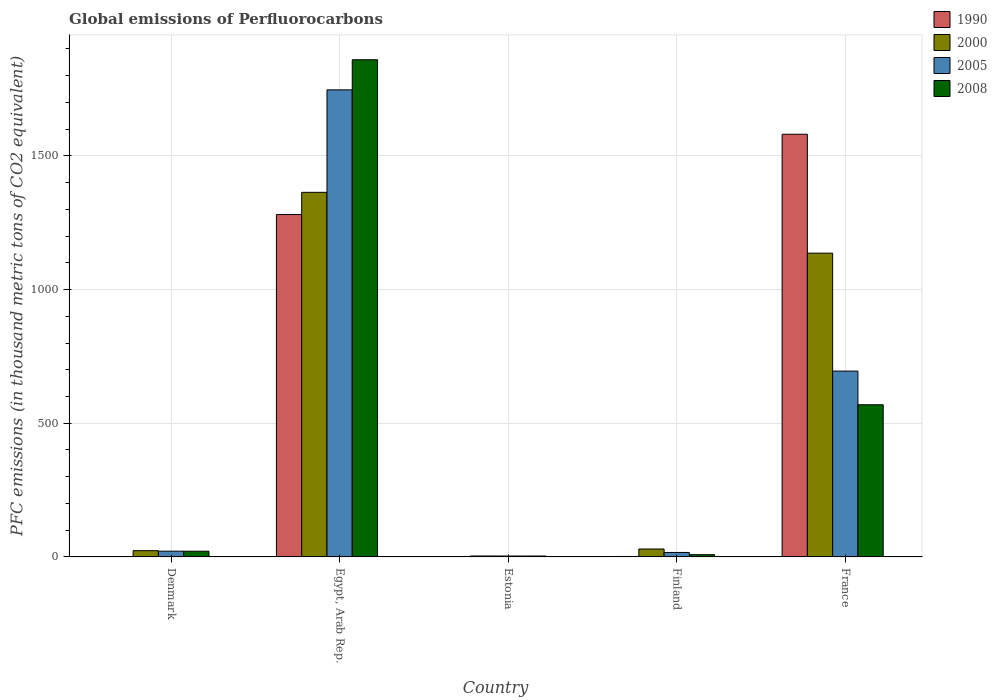How many groups of bars are there?
Your answer should be very brief. 5. What is the label of the 5th group of bars from the left?
Your answer should be very brief. France. In how many cases, is the number of bars for a given country not equal to the number of legend labels?
Your answer should be very brief. 0. Across all countries, what is the maximum global emissions of Perfluorocarbons in 2000?
Provide a succinct answer. 1363.8. Across all countries, what is the minimum global emissions of Perfluorocarbons in 2005?
Provide a short and direct response. 3.4. In which country was the global emissions of Perfluorocarbons in 2008 maximum?
Keep it short and to the point. Egypt, Arab Rep. In which country was the global emissions of Perfluorocarbons in 2005 minimum?
Provide a succinct answer. Estonia. What is the total global emissions of Perfluorocarbons in 2000 in the graph?
Make the answer very short. 2556.7. What is the difference between the global emissions of Perfluorocarbons in 2000 in Denmark and that in Finland?
Your answer should be compact. -6.3. What is the difference between the global emissions of Perfluorocarbons in 2005 in Denmark and the global emissions of Perfluorocarbons in 1990 in Finland?
Make the answer very short. 19.8. What is the average global emissions of Perfluorocarbons in 1990 per country?
Keep it short and to the point. 573.1. What is the difference between the global emissions of Perfluorocarbons of/in 2005 and global emissions of Perfluorocarbons of/in 2008 in Egypt, Arab Rep.?
Offer a very short reply. -112.7. What is the ratio of the global emissions of Perfluorocarbons in 1990 in Egypt, Arab Rep. to that in Finland?
Your answer should be very brief. 753.41. Is the global emissions of Perfluorocarbons in 2005 in Denmark less than that in Finland?
Provide a short and direct response. No. What is the difference between the highest and the second highest global emissions of Perfluorocarbons in 2005?
Provide a succinct answer. 1725.6. What is the difference between the highest and the lowest global emissions of Perfluorocarbons in 2000?
Offer a terse response. 1360.3. In how many countries, is the global emissions of Perfluorocarbons in 2008 greater than the average global emissions of Perfluorocarbons in 2008 taken over all countries?
Give a very brief answer. 2. Are all the bars in the graph horizontal?
Your answer should be very brief. No. How many countries are there in the graph?
Offer a terse response. 5. What is the difference between two consecutive major ticks on the Y-axis?
Provide a short and direct response. 500. Are the values on the major ticks of Y-axis written in scientific E-notation?
Provide a short and direct response. No. Where does the legend appear in the graph?
Your answer should be compact. Top right. How many legend labels are there?
Make the answer very short. 4. How are the legend labels stacked?
Your response must be concise. Vertical. What is the title of the graph?
Make the answer very short. Global emissions of Perfluorocarbons. Does "1989" appear as one of the legend labels in the graph?
Your answer should be very brief. No. What is the label or title of the X-axis?
Provide a short and direct response. Country. What is the label or title of the Y-axis?
Give a very brief answer. PFC emissions (in thousand metric tons of CO2 equivalent). What is the PFC emissions (in thousand metric tons of CO2 equivalent) of 2000 in Denmark?
Offer a terse response. 23.4. What is the PFC emissions (in thousand metric tons of CO2 equivalent) in 2005 in Denmark?
Make the answer very short. 21.5. What is the PFC emissions (in thousand metric tons of CO2 equivalent) in 2008 in Denmark?
Make the answer very short. 21.4. What is the PFC emissions (in thousand metric tons of CO2 equivalent) of 1990 in Egypt, Arab Rep.?
Keep it short and to the point. 1280.8. What is the PFC emissions (in thousand metric tons of CO2 equivalent) of 2000 in Egypt, Arab Rep.?
Your response must be concise. 1363.8. What is the PFC emissions (in thousand metric tons of CO2 equivalent) of 2005 in Egypt, Arab Rep.?
Your response must be concise. 1747.1. What is the PFC emissions (in thousand metric tons of CO2 equivalent) in 2008 in Egypt, Arab Rep.?
Offer a very short reply. 1859.8. What is the PFC emissions (in thousand metric tons of CO2 equivalent) in 1990 in Estonia?
Provide a succinct answer. 0.5. What is the PFC emissions (in thousand metric tons of CO2 equivalent) of 2008 in Estonia?
Offer a terse response. 3.4. What is the PFC emissions (in thousand metric tons of CO2 equivalent) in 2000 in Finland?
Make the answer very short. 29.7. What is the PFC emissions (in thousand metric tons of CO2 equivalent) in 2005 in Finland?
Your response must be concise. 16.7. What is the PFC emissions (in thousand metric tons of CO2 equivalent) of 1990 in France?
Offer a terse response. 1581.1. What is the PFC emissions (in thousand metric tons of CO2 equivalent) in 2000 in France?
Offer a very short reply. 1136.3. What is the PFC emissions (in thousand metric tons of CO2 equivalent) of 2005 in France?
Your response must be concise. 695.1. What is the PFC emissions (in thousand metric tons of CO2 equivalent) in 2008 in France?
Offer a very short reply. 569.2. Across all countries, what is the maximum PFC emissions (in thousand metric tons of CO2 equivalent) in 1990?
Keep it short and to the point. 1581.1. Across all countries, what is the maximum PFC emissions (in thousand metric tons of CO2 equivalent) in 2000?
Your answer should be very brief. 1363.8. Across all countries, what is the maximum PFC emissions (in thousand metric tons of CO2 equivalent) in 2005?
Provide a succinct answer. 1747.1. Across all countries, what is the maximum PFC emissions (in thousand metric tons of CO2 equivalent) in 2008?
Provide a short and direct response. 1859.8. Across all countries, what is the minimum PFC emissions (in thousand metric tons of CO2 equivalent) of 2005?
Your answer should be compact. 3.4. Across all countries, what is the minimum PFC emissions (in thousand metric tons of CO2 equivalent) in 2008?
Give a very brief answer. 3.4. What is the total PFC emissions (in thousand metric tons of CO2 equivalent) in 1990 in the graph?
Make the answer very short. 2865.5. What is the total PFC emissions (in thousand metric tons of CO2 equivalent) in 2000 in the graph?
Your answer should be compact. 2556.7. What is the total PFC emissions (in thousand metric tons of CO2 equivalent) in 2005 in the graph?
Provide a short and direct response. 2483.8. What is the total PFC emissions (in thousand metric tons of CO2 equivalent) of 2008 in the graph?
Provide a short and direct response. 2462.2. What is the difference between the PFC emissions (in thousand metric tons of CO2 equivalent) of 1990 in Denmark and that in Egypt, Arab Rep.?
Your response must be concise. -1279.4. What is the difference between the PFC emissions (in thousand metric tons of CO2 equivalent) of 2000 in Denmark and that in Egypt, Arab Rep.?
Your response must be concise. -1340.4. What is the difference between the PFC emissions (in thousand metric tons of CO2 equivalent) of 2005 in Denmark and that in Egypt, Arab Rep.?
Give a very brief answer. -1725.6. What is the difference between the PFC emissions (in thousand metric tons of CO2 equivalent) of 2008 in Denmark and that in Egypt, Arab Rep.?
Give a very brief answer. -1838.4. What is the difference between the PFC emissions (in thousand metric tons of CO2 equivalent) of 1990 in Denmark and that in Estonia?
Ensure brevity in your answer.  0.9. What is the difference between the PFC emissions (in thousand metric tons of CO2 equivalent) of 2005 in Denmark and that in Estonia?
Your response must be concise. 18.1. What is the difference between the PFC emissions (in thousand metric tons of CO2 equivalent) of 2000 in Denmark and that in Finland?
Provide a short and direct response. -6.3. What is the difference between the PFC emissions (in thousand metric tons of CO2 equivalent) in 1990 in Denmark and that in France?
Make the answer very short. -1579.7. What is the difference between the PFC emissions (in thousand metric tons of CO2 equivalent) in 2000 in Denmark and that in France?
Your answer should be compact. -1112.9. What is the difference between the PFC emissions (in thousand metric tons of CO2 equivalent) in 2005 in Denmark and that in France?
Offer a terse response. -673.6. What is the difference between the PFC emissions (in thousand metric tons of CO2 equivalent) in 2008 in Denmark and that in France?
Your answer should be very brief. -547.8. What is the difference between the PFC emissions (in thousand metric tons of CO2 equivalent) in 1990 in Egypt, Arab Rep. and that in Estonia?
Make the answer very short. 1280.3. What is the difference between the PFC emissions (in thousand metric tons of CO2 equivalent) of 2000 in Egypt, Arab Rep. and that in Estonia?
Offer a terse response. 1360.3. What is the difference between the PFC emissions (in thousand metric tons of CO2 equivalent) of 2005 in Egypt, Arab Rep. and that in Estonia?
Offer a very short reply. 1743.7. What is the difference between the PFC emissions (in thousand metric tons of CO2 equivalent) of 2008 in Egypt, Arab Rep. and that in Estonia?
Make the answer very short. 1856.4. What is the difference between the PFC emissions (in thousand metric tons of CO2 equivalent) in 1990 in Egypt, Arab Rep. and that in Finland?
Provide a succinct answer. 1279.1. What is the difference between the PFC emissions (in thousand metric tons of CO2 equivalent) of 2000 in Egypt, Arab Rep. and that in Finland?
Provide a succinct answer. 1334.1. What is the difference between the PFC emissions (in thousand metric tons of CO2 equivalent) of 2005 in Egypt, Arab Rep. and that in Finland?
Your answer should be very brief. 1730.4. What is the difference between the PFC emissions (in thousand metric tons of CO2 equivalent) in 2008 in Egypt, Arab Rep. and that in Finland?
Provide a succinct answer. 1851.4. What is the difference between the PFC emissions (in thousand metric tons of CO2 equivalent) in 1990 in Egypt, Arab Rep. and that in France?
Give a very brief answer. -300.3. What is the difference between the PFC emissions (in thousand metric tons of CO2 equivalent) in 2000 in Egypt, Arab Rep. and that in France?
Offer a terse response. 227.5. What is the difference between the PFC emissions (in thousand metric tons of CO2 equivalent) of 2005 in Egypt, Arab Rep. and that in France?
Your answer should be very brief. 1052. What is the difference between the PFC emissions (in thousand metric tons of CO2 equivalent) in 2008 in Egypt, Arab Rep. and that in France?
Ensure brevity in your answer.  1290.6. What is the difference between the PFC emissions (in thousand metric tons of CO2 equivalent) of 2000 in Estonia and that in Finland?
Your response must be concise. -26.2. What is the difference between the PFC emissions (in thousand metric tons of CO2 equivalent) in 1990 in Estonia and that in France?
Offer a terse response. -1580.6. What is the difference between the PFC emissions (in thousand metric tons of CO2 equivalent) of 2000 in Estonia and that in France?
Give a very brief answer. -1132.8. What is the difference between the PFC emissions (in thousand metric tons of CO2 equivalent) in 2005 in Estonia and that in France?
Offer a terse response. -691.7. What is the difference between the PFC emissions (in thousand metric tons of CO2 equivalent) of 2008 in Estonia and that in France?
Provide a succinct answer. -565.8. What is the difference between the PFC emissions (in thousand metric tons of CO2 equivalent) of 1990 in Finland and that in France?
Your response must be concise. -1579.4. What is the difference between the PFC emissions (in thousand metric tons of CO2 equivalent) in 2000 in Finland and that in France?
Make the answer very short. -1106.6. What is the difference between the PFC emissions (in thousand metric tons of CO2 equivalent) of 2005 in Finland and that in France?
Provide a short and direct response. -678.4. What is the difference between the PFC emissions (in thousand metric tons of CO2 equivalent) in 2008 in Finland and that in France?
Keep it short and to the point. -560.8. What is the difference between the PFC emissions (in thousand metric tons of CO2 equivalent) in 1990 in Denmark and the PFC emissions (in thousand metric tons of CO2 equivalent) in 2000 in Egypt, Arab Rep.?
Your response must be concise. -1362.4. What is the difference between the PFC emissions (in thousand metric tons of CO2 equivalent) in 1990 in Denmark and the PFC emissions (in thousand metric tons of CO2 equivalent) in 2005 in Egypt, Arab Rep.?
Your answer should be compact. -1745.7. What is the difference between the PFC emissions (in thousand metric tons of CO2 equivalent) of 1990 in Denmark and the PFC emissions (in thousand metric tons of CO2 equivalent) of 2008 in Egypt, Arab Rep.?
Give a very brief answer. -1858.4. What is the difference between the PFC emissions (in thousand metric tons of CO2 equivalent) in 2000 in Denmark and the PFC emissions (in thousand metric tons of CO2 equivalent) in 2005 in Egypt, Arab Rep.?
Keep it short and to the point. -1723.7. What is the difference between the PFC emissions (in thousand metric tons of CO2 equivalent) in 2000 in Denmark and the PFC emissions (in thousand metric tons of CO2 equivalent) in 2008 in Egypt, Arab Rep.?
Your answer should be very brief. -1836.4. What is the difference between the PFC emissions (in thousand metric tons of CO2 equivalent) of 2005 in Denmark and the PFC emissions (in thousand metric tons of CO2 equivalent) of 2008 in Egypt, Arab Rep.?
Your response must be concise. -1838.3. What is the difference between the PFC emissions (in thousand metric tons of CO2 equivalent) in 1990 in Denmark and the PFC emissions (in thousand metric tons of CO2 equivalent) in 2005 in Estonia?
Your answer should be very brief. -2. What is the difference between the PFC emissions (in thousand metric tons of CO2 equivalent) of 1990 in Denmark and the PFC emissions (in thousand metric tons of CO2 equivalent) of 2008 in Estonia?
Your answer should be compact. -2. What is the difference between the PFC emissions (in thousand metric tons of CO2 equivalent) in 2000 in Denmark and the PFC emissions (in thousand metric tons of CO2 equivalent) in 2008 in Estonia?
Offer a terse response. 20. What is the difference between the PFC emissions (in thousand metric tons of CO2 equivalent) in 2005 in Denmark and the PFC emissions (in thousand metric tons of CO2 equivalent) in 2008 in Estonia?
Offer a very short reply. 18.1. What is the difference between the PFC emissions (in thousand metric tons of CO2 equivalent) of 1990 in Denmark and the PFC emissions (in thousand metric tons of CO2 equivalent) of 2000 in Finland?
Make the answer very short. -28.3. What is the difference between the PFC emissions (in thousand metric tons of CO2 equivalent) of 1990 in Denmark and the PFC emissions (in thousand metric tons of CO2 equivalent) of 2005 in Finland?
Provide a succinct answer. -15.3. What is the difference between the PFC emissions (in thousand metric tons of CO2 equivalent) in 1990 in Denmark and the PFC emissions (in thousand metric tons of CO2 equivalent) in 2000 in France?
Provide a succinct answer. -1134.9. What is the difference between the PFC emissions (in thousand metric tons of CO2 equivalent) of 1990 in Denmark and the PFC emissions (in thousand metric tons of CO2 equivalent) of 2005 in France?
Your answer should be compact. -693.7. What is the difference between the PFC emissions (in thousand metric tons of CO2 equivalent) in 1990 in Denmark and the PFC emissions (in thousand metric tons of CO2 equivalent) in 2008 in France?
Give a very brief answer. -567.8. What is the difference between the PFC emissions (in thousand metric tons of CO2 equivalent) of 2000 in Denmark and the PFC emissions (in thousand metric tons of CO2 equivalent) of 2005 in France?
Your response must be concise. -671.7. What is the difference between the PFC emissions (in thousand metric tons of CO2 equivalent) of 2000 in Denmark and the PFC emissions (in thousand metric tons of CO2 equivalent) of 2008 in France?
Provide a succinct answer. -545.8. What is the difference between the PFC emissions (in thousand metric tons of CO2 equivalent) in 2005 in Denmark and the PFC emissions (in thousand metric tons of CO2 equivalent) in 2008 in France?
Ensure brevity in your answer.  -547.7. What is the difference between the PFC emissions (in thousand metric tons of CO2 equivalent) of 1990 in Egypt, Arab Rep. and the PFC emissions (in thousand metric tons of CO2 equivalent) of 2000 in Estonia?
Your response must be concise. 1277.3. What is the difference between the PFC emissions (in thousand metric tons of CO2 equivalent) in 1990 in Egypt, Arab Rep. and the PFC emissions (in thousand metric tons of CO2 equivalent) in 2005 in Estonia?
Your response must be concise. 1277.4. What is the difference between the PFC emissions (in thousand metric tons of CO2 equivalent) of 1990 in Egypt, Arab Rep. and the PFC emissions (in thousand metric tons of CO2 equivalent) of 2008 in Estonia?
Ensure brevity in your answer.  1277.4. What is the difference between the PFC emissions (in thousand metric tons of CO2 equivalent) in 2000 in Egypt, Arab Rep. and the PFC emissions (in thousand metric tons of CO2 equivalent) in 2005 in Estonia?
Offer a very short reply. 1360.4. What is the difference between the PFC emissions (in thousand metric tons of CO2 equivalent) in 2000 in Egypt, Arab Rep. and the PFC emissions (in thousand metric tons of CO2 equivalent) in 2008 in Estonia?
Provide a short and direct response. 1360.4. What is the difference between the PFC emissions (in thousand metric tons of CO2 equivalent) of 2005 in Egypt, Arab Rep. and the PFC emissions (in thousand metric tons of CO2 equivalent) of 2008 in Estonia?
Give a very brief answer. 1743.7. What is the difference between the PFC emissions (in thousand metric tons of CO2 equivalent) of 1990 in Egypt, Arab Rep. and the PFC emissions (in thousand metric tons of CO2 equivalent) of 2000 in Finland?
Your answer should be very brief. 1251.1. What is the difference between the PFC emissions (in thousand metric tons of CO2 equivalent) of 1990 in Egypt, Arab Rep. and the PFC emissions (in thousand metric tons of CO2 equivalent) of 2005 in Finland?
Your response must be concise. 1264.1. What is the difference between the PFC emissions (in thousand metric tons of CO2 equivalent) of 1990 in Egypt, Arab Rep. and the PFC emissions (in thousand metric tons of CO2 equivalent) of 2008 in Finland?
Provide a succinct answer. 1272.4. What is the difference between the PFC emissions (in thousand metric tons of CO2 equivalent) in 2000 in Egypt, Arab Rep. and the PFC emissions (in thousand metric tons of CO2 equivalent) in 2005 in Finland?
Give a very brief answer. 1347.1. What is the difference between the PFC emissions (in thousand metric tons of CO2 equivalent) of 2000 in Egypt, Arab Rep. and the PFC emissions (in thousand metric tons of CO2 equivalent) of 2008 in Finland?
Your response must be concise. 1355.4. What is the difference between the PFC emissions (in thousand metric tons of CO2 equivalent) in 2005 in Egypt, Arab Rep. and the PFC emissions (in thousand metric tons of CO2 equivalent) in 2008 in Finland?
Offer a terse response. 1738.7. What is the difference between the PFC emissions (in thousand metric tons of CO2 equivalent) in 1990 in Egypt, Arab Rep. and the PFC emissions (in thousand metric tons of CO2 equivalent) in 2000 in France?
Offer a terse response. 144.5. What is the difference between the PFC emissions (in thousand metric tons of CO2 equivalent) in 1990 in Egypt, Arab Rep. and the PFC emissions (in thousand metric tons of CO2 equivalent) in 2005 in France?
Offer a very short reply. 585.7. What is the difference between the PFC emissions (in thousand metric tons of CO2 equivalent) in 1990 in Egypt, Arab Rep. and the PFC emissions (in thousand metric tons of CO2 equivalent) in 2008 in France?
Provide a succinct answer. 711.6. What is the difference between the PFC emissions (in thousand metric tons of CO2 equivalent) in 2000 in Egypt, Arab Rep. and the PFC emissions (in thousand metric tons of CO2 equivalent) in 2005 in France?
Offer a terse response. 668.7. What is the difference between the PFC emissions (in thousand metric tons of CO2 equivalent) in 2000 in Egypt, Arab Rep. and the PFC emissions (in thousand metric tons of CO2 equivalent) in 2008 in France?
Your answer should be compact. 794.6. What is the difference between the PFC emissions (in thousand metric tons of CO2 equivalent) of 2005 in Egypt, Arab Rep. and the PFC emissions (in thousand metric tons of CO2 equivalent) of 2008 in France?
Give a very brief answer. 1177.9. What is the difference between the PFC emissions (in thousand metric tons of CO2 equivalent) of 1990 in Estonia and the PFC emissions (in thousand metric tons of CO2 equivalent) of 2000 in Finland?
Ensure brevity in your answer.  -29.2. What is the difference between the PFC emissions (in thousand metric tons of CO2 equivalent) of 1990 in Estonia and the PFC emissions (in thousand metric tons of CO2 equivalent) of 2005 in Finland?
Make the answer very short. -16.2. What is the difference between the PFC emissions (in thousand metric tons of CO2 equivalent) of 2000 in Estonia and the PFC emissions (in thousand metric tons of CO2 equivalent) of 2008 in Finland?
Make the answer very short. -4.9. What is the difference between the PFC emissions (in thousand metric tons of CO2 equivalent) in 2005 in Estonia and the PFC emissions (in thousand metric tons of CO2 equivalent) in 2008 in Finland?
Offer a terse response. -5. What is the difference between the PFC emissions (in thousand metric tons of CO2 equivalent) in 1990 in Estonia and the PFC emissions (in thousand metric tons of CO2 equivalent) in 2000 in France?
Provide a short and direct response. -1135.8. What is the difference between the PFC emissions (in thousand metric tons of CO2 equivalent) of 1990 in Estonia and the PFC emissions (in thousand metric tons of CO2 equivalent) of 2005 in France?
Provide a short and direct response. -694.6. What is the difference between the PFC emissions (in thousand metric tons of CO2 equivalent) of 1990 in Estonia and the PFC emissions (in thousand metric tons of CO2 equivalent) of 2008 in France?
Give a very brief answer. -568.7. What is the difference between the PFC emissions (in thousand metric tons of CO2 equivalent) of 2000 in Estonia and the PFC emissions (in thousand metric tons of CO2 equivalent) of 2005 in France?
Provide a short and direct response. -691.6. What is the difference between the PFC emissions (in thousand metric tons of CO2 equivalent) in 2000 in Estonia and the PFC emissions (in thousand metric tons of CO2 equivalent) in 2008 in France?
Keep it short and to the point. -565.7. What is the difference between the PFC emissions (in thousand metric tons of CO2 equivalent) of 2005 in Estonia and the PFC emissions (in thousand metric tons of CO2 equivalent) of 2008 in France?
Your response must be concise. -565.8. What is the difference between the PFC emissions (in thousand metric tons of CO2 equivalent) in 1990 in Finland and the PFC emissions (in thousand metric tons of CO2 equivalent) in 2000 in France?
Offer a very short reply. -1134.6. What is the difference between the PFC emissions (in thousand metric tons of CO2 equivalent) of 1990 in Finland and the PFC emissions (in thousand metric tons of CO2 equivalent) of 2005 in France?
Your response must be concise. -693.4. What is the difference between the PFC emissions (in thousand metric tons of CO2 equivalent) of 1990 in Finland and the PFC emissions (in thousand metric tons of CO2 equivalent) of 2008 in France?
Ensure brevity in your answer.  -567.5. What is the difference between the PFC emissions (in thousand metric tons of CO2 equivalent) of 2000 in Finland and the PFC emissions (in thousand metric tons of CO2 equivalent) of 2005 in France?
Your response must be concise. -665.4. What is the difference between the PFC emissions (in thousand metric tons of CO2 equivalent) of 2000 in Finland and the PFC emissions (in thousand metric tons of CO2 equivalent) of 2008 in France?
Your answer should be compact. -539.5. What is the difference between the PFC emissions (in thousand metric tons of CO2 equivalent) in 2005 in Finland and the PFC emissions (in thousand metric tons of CO2 equivalent) in 2008 in France?
Your answer should be compact. -552.5. What is the average PFC emissions (in thousand metric tons of CO2 equivalent) in 1990 per country?
Keep it short and to the point. 573.1. What is the average PFC emissions (in thousand metric tons of CO2 equivalent) in 2000 per country?
Make the answer very short. 511.34. What is the average PFC emissions (in thousand metric tons of CO2 equivalent) in 2005 per country?
Give a very brief answer. 496.76. What is the average PFC emissions (in thousand metric tons of CO2 equivalent) in 2008 per country?
Provide a short and direct response. 492.44. What is the difference between the PFC emissions (in thousand metric tons of CO2 equivalent) of 1990 and PFC emissions (in thousand metric tons of CO2 equivalent) of 2005 in Denmark?
Keep it short and to the point. -20.1. What is the difference between the PFC emissions (in thousand metric tons of CO2 equivalent) in 2000 and PFC emissions (in thousand metric tons of CO2 equivalent) in 2008 in Denmark?
Your answer should be very brief. 2. What is the difference between the PFC emissions (in thousand metric tons of CO2 equivalent) in 1990 and PFC emissions (in thousand metric tons of CO2 equivalent) in 2000 in Egypt, Arab Rep.?
Your response must be concise. -83. What is the difference between the PFC emissions (in thousand metric tons of CO2 equivalent) in 1990 and PFC emissions (in thousand metric tons of CO2 equivalent) in 2005 in Egypt, Arab Rep.?
Keep it short and to the point. -466.3. What is the difference between the PFC emissions (in thousand metric tons of CO2 equivalent) in 1990 and PFC emissions (in thousand metric tons of CO2 equivalent) in 2008 in Egypt, Arab Rep.?
Keep it short and to the point. -579. What is the difference between the PFC emissions (in thousand metric tons of CO2 equivalent) in 2000 and PFC emissions (in thousand metric tons of CO2 equivalent) in 2005 in Egypt, Arab Rep.?
Offer a very short reply. -383.3. What is the difference between the PFC emissions (in thousand metric tons of CO2 equivalent) of 2000 and PFC emissions (in thousand metric tons of CO2 equivalent) of 2008 in Egypt, Arab Rep.?
Make the answer very short. -496. What is the difference between the PFC emissions (in thousand metric tons of CO2 equivalent) in 2005 and PFC emissions (in thousand metric tons of CO2 equivalent) in 2008 in Egypt, Arab Rep.?
Keep it short and to the point. -112.7. What is the difference between the PFC emissions (in thousand metric tons of CO2 equivalent) of 1990 and PFC emissions (in thousand metric tons of CO2 equivalent) of 2005 in Estonia?
Your answer should be compact. -2.9. What is the difference between the PFC emissions (in thousand metric tons of CO2 equivalent) of 2000 and PFC emissions (in thousand metric tons of CO2 equivalent) of 2008 in Estonia?
Ensure brevity in your answer.  0.1. What is the difference between the PFC emissions (in thousand metric tons of CO2 equivalent) of 1990 and PFC emissions (in thousand metric tons of CO2 equivalent) of 2000 in Finland?
Give a very brief answer. -28. What is the difference between the PFC emissions (in thousand metric tons of CO2 equivalent) of 2000 and PFC emissions (in thousand metric tons of CO2 equivalent) of 2008 in Finland?
Your answer should be very brief. 21.3. What is the difference between the PFC emissions (in thousand metric tons of CO2 equivalent) of 2005 and PFC emissions (in thousand metric tons of CO2 equivalent) of 2008 in Finland?
Your response must be concise. 8.3. What is the difference between the PFC emissions (in thousand metric tons of CO2 equivalent) in 1990 and PFC emissions (in thousand metric tons of CO2 equivalent) in 2000 in France?
Your response must be concise. 444.8. What is the difference between the PFC emissions (in thousand metric tons of CO2 equivalent) in 1990 and PFC emissions (in thousand metric tons of CO2 equivalent) in 2005 in France?
Ensure brevity in your answer.  886. What is the difference between the PFC emissions (in thousand metric tons of CO2 equivalent) of 1990 and PFC emissions (in thousand metric tons of CO2 equivalent) of 2008 in France?
Provide a succinct answer. 1011.9. What is the difference between the PFC emissions (in thousand metric tons of CO2 equivalent) of 2000 and PFC emissions (in thousand metric tons of CO2 equivalent) of 2005 in France?
Offer a very short reply. 441.2. What is the difference between the PFC emissions (in thousand metric tons of CO2 equivalent) in 2000 and PFC emissions (in thousand metric tons of CO2 equivalent) in 2008 in France?
Provide a short and direct response. 567.1. What is the difference between the PFC emissions (in thousand metric tons of CO2 equivalent) in 2005 and PFC emissions (in thousand metric tons of CO2 equivalent) in 2008 in France?
Make the answer very short. 125.9. What is the ratio of the PFC emissions (in thousand metric tons of CO2 equivalent) of 1990 in Denmark to that in Egypt, Arab Rep.?
Offer a terse response. 0. What is the ratio of the PFC emissions (in thousand metric tons of CO2 equivalent) in 2000 in Denmark to that in Egypt, Arab Rep.?
Your answer should be compact. 0.02. What is the ratio of the PFC emissions (in thousand metric tons of CO2 equivalent) of 2005 in Denmark to that in Egypt, Arab Rep.?
Provide a short and direct response. 0.01. What is the ratio of the PFC emissions (in thousand metric tons of CO2 equivalent) in 2008 in Denmark to that in Egypt, Arab Rep.?
Keep it short and to the point. 0.01. What is the ratio of the PFC emissions (in thousand metric tons of CO2 equivalent) of 1990 in Denmark to that in Estonia?
Provide a succinct answer. 2.8. What is the ratio of the PFC emissions (in thousand metric tons of CO2 equivalent) of 2000 in Denmark to that in Estonia?
Your answer should be compact. 6.69. What is the ratio of the PFC emissions (in thousand metric tons of CO2 equivalent) of 2005 in Denmark to that in Estonia?
Offer a very short reply. 6.32. What is the ratio of the PFC emissions (in thousand metric tons of CO2 equivalent) in 2008 in Denmark to that in Estonia?
Make the answer very short. 6.29. What is the ratio of the PFC emissions (in thousand metric tons of CO2 equivalent) of 1990 in Denmark to that in Finland?
Make the answer very short. 0.82. What is the ratio of the PFC emissions (in thousand metric tons of CO2 equivalent) in 2000 in Denmark to that in Finland?
Your response must be concise. 0.79. What is the ratio of the PFC emissions (in thousand metric tons of CO2 equivalent) of 2005 in Denmark to that in Finland?
Your answer should be very brief. 1.29. What is the ratio of the PFC emissions (in thousand metric tons of CO2 equivalent) of 2008 in Denmark to that in Finland?
Offer a very short reply. 2.55. What is the ratio of the PFC emissions (in thousand metric tons of CO2 equivalent) in 1990 in Denmark to that in France?
Your answer should be compact. 0. What is the ratio of the PFC emissions (in thousand metric tons of CO2 equivalent) of 2000 in Denmark to that in France?
Make the answer very short. 0.02. What is the ratio of the PFC emissions (in thousand metric tons of CO2 equivalent) in 2005 in Denmark to that in France?
Your answer should be compact. 0.03. What is the ratio of the PFC emissions (in thousand metric tons of CO2 equivalent) of 2008 in Denmark to that in France?
Your response must be concise. 0.04. What is the ratio of the PFC emissions (in thousand metric tons of CO2 equivalent) in 1990 in Egypt, Arab Rep. to that in Estonia?
Provide a short and direct response. 2561.6. What is the ratio of the PFC emissions (in thousand metric tons of CO2 equivalent) of 2000 in Egypt, Arab Rep. to that in Estonia?
Provide a short and direct response. 389.66. What is the ratio of the PFC emissions (in thousand metric tons of CO2 equivalent) in 2005 in Egypt, Arab Rep. to that in Estonia?
Offer a terse response. 513.85. What is the ratio of the PFC emissions (in thousand metric tons of CO2 equivalent) of 2008 in Egypt, Arab Rep. to that in Estonia?
Provide a short and direct response. 547. What is the ratio of the PFC emissions (in thousand metric tons of CO2 equivalent) in 1990 in Egypt, Arab Rep. to that in Finland?
Your answer should be compact. 753.41. What is the ratio of the PFC emissions (in thousand metric tons of CO2 equivalent) of 2000 in Egypt, Arab Rep. to that in Finland?
Offer a terse response. 45.92. What is the ratio of the PFC emissions (in thousand metric tons of CO2 equivalent) in 2005 in Egypt, Arab Rep. to that in Finland?
Make the answer very short. 104.62. What is the ratio of the PFC emissions (in thousand metric tons of CO2 equivalent) of 2008 in Egypt, Arab Rep. to that in Finland?
Give a very brief answer. 221.4. What is the ratio of the PFC emissions (in thousand metric tons of CO2 equivalent) of 1990 in Egypt, Arab Rep. to that in France?
Your response must be concise. 0.81. What is the ratio of the PFC emissions (in thousand metric tons of CO2 equivalent) in 2000 in Egypt, Arab Rep. to that in France?
Offer a terse response. 1.2. What is the ratio of the PFC emissions (in thousand metric tons of CO2 equivalent) in 2005 in Egypt, Arab Rep. to that in France?
Offer a very short reply. 2.51. What is the ratio of the PFC emissions (in thousand metric tons of CO2 equivalent) in 2008 in Egypt, Arab Rep. to that in France?
Offer a very short reply. 3.27. What is the ratio of the PFC emissions (in thousand metric tons of CO2 equivalent) of 1990 in Estonia to that in Finland?
Keep it short and to the point. 0.29. What is the ratio of the PFC emissions (in thousand metric tons of CO2 equivalent) in 2000 in Estonia to that in Finland?
Keep it short and to the point. 0.12. What is the ratio of the PFC emissions (in thousand metric tons of CO2 equivalent) of 2005 in Estonia to that in Finland?
Offer a very short reply. 0.2. What is the ratio of the PFC emissions (in thousand metric tons of CO2 equivalent) in 2008 in Estonia to that in Finland?
Offer a terse response. 0.4. What is the ratio of the PFC emissions (in thousand metric tons of CO2 equivalent) in 2000 in Estonia to that in France?
Ensure brevity in your answer.  0. What is the ratio of the PFC emissions (in thousand metric tons of CO2 equivalent) of 2005 in Estonia to that in France?
Keep it short and to the point. 0. What is the ratio of the PFC emissions (in thousand metric tons of CO2 equivalent) of 2008 in Estonia to that in France?
Keep it short and to the point. 0.01. What is the ratio of the PFC emissions (in thousand metric tons of CO2 equivalent) in 1990 in Finland to that in France?
Ensure brevity in your answer.  0. What is the ratio of the PFC emissions (in thousand metric tons of CO2 equivalent) of 2000 in Finland to that in France?
Offer a very short reply. 0.03. What is the ratio of the PFC emissions (in thousand metric tons of CO2 equivalent) in 2005 in Finland to that in France?
Make the answer very short. 0.02. What is the ratio of the PFC emissions (in thousand metric tons of CO2 equivalent) of 2008 in Finland to that in France?
Your answer should be compact. 0.01. What is the difference between the highest and the second highest PFC emissions (in thousand metric tons of CO2 equivalent) in 1990?
Make the answer very short. 300.3. What is the difference between the highest and the second highest PFC emissions (in thousand metric tons of CO2 equivalent) in 2000?
Your answer should be compact. 227.5. What is the difference between the highest and the second highest PFC emissions (in thousand metric tons of CO2 equivalent) of 2005?
Your answer should be very brief. 1052. What is the difference between the highest and the second highest PFC emissions (in thousand metric tons of CO2 equivalent) in 2008?
Your answer should be very brief. 1290.6. What is the difference between the highest and the lowest PFC emissions (in thousand metric tons of CO2 equivalent) in 1990?
Your answer should be compact. 1580.6. What is the difference between the highest and the lowest PFC emissions (in thousand metric tons of CO2 equivalent) in 2000?
Offer a very short reply. 1360.3. What is the difference between the highest and the lowest PFC emissions (in thousand metric tons of CO2 equivalent) of 2005?
Give a very brief answer. 1743.7. What is the difference between the highest and the lowest PFC emissions (in thousand metric tons of CO2 equivalent) of 2008?
Offer a terse response. 1856.4. 